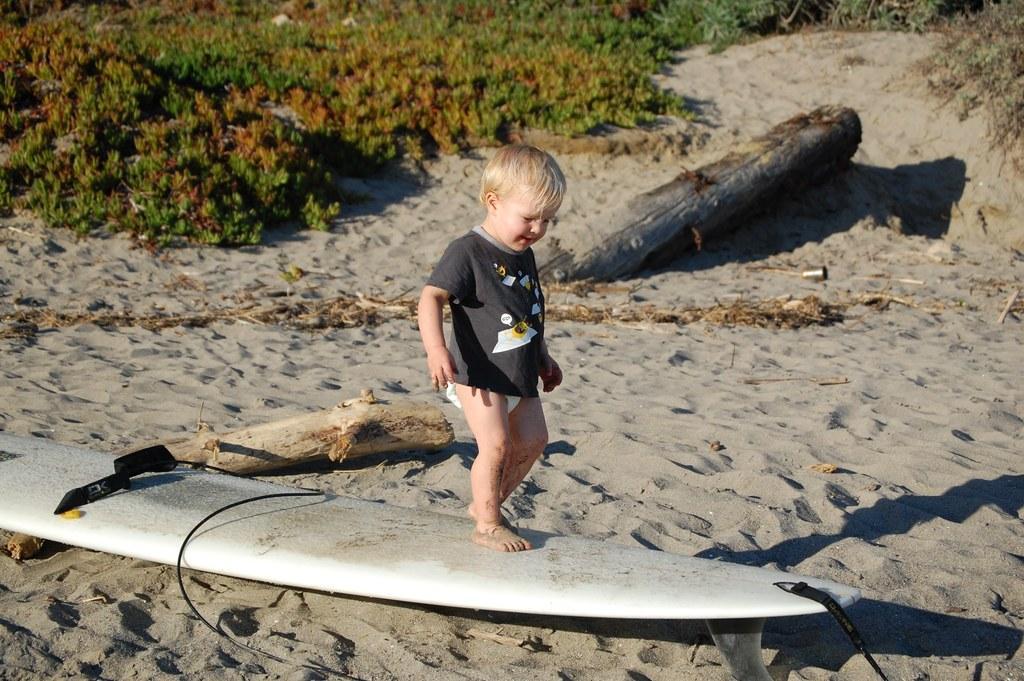Can you describe this image briefly? In this image we can see there is a little boy standing on the surfing board, which is on the surface of the sand, behind the boy there are two wooden sticks and grass. 